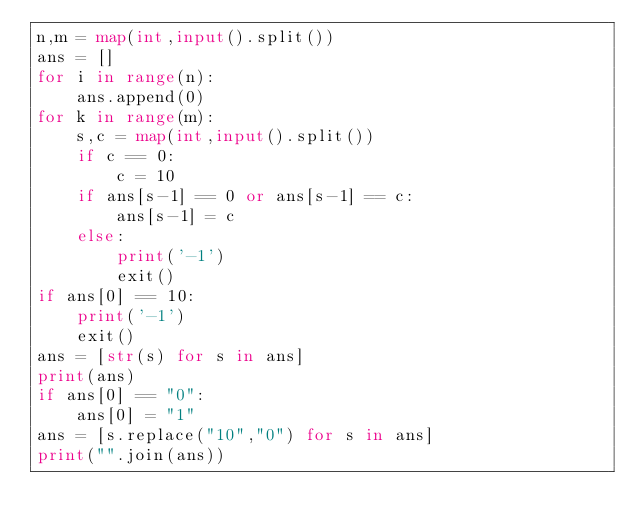<code> <loc_0><loc_0><loc_500><loc_500><_Python_>n,m = map(int,input().split())
ans = []
for i in range(n):
    ans.append(0)
for k in range(m):
    s,c = map(int,input().split())
    if c == 0:
        c = 10    
    if ans[s-1] == 0 or ans[s-1] == c:
        ans[s-1] = c
    else:
        print('-1')
        exit()
if ans[0] == 10:
    print('-1')
    exit()
ans = [str(s) for s in ans]
print(ans)
if ans[0] == "0":
    ans[0] = "1"
ans = [s.replace("10","0") for s in ans]
print("".join(ans))</code> 